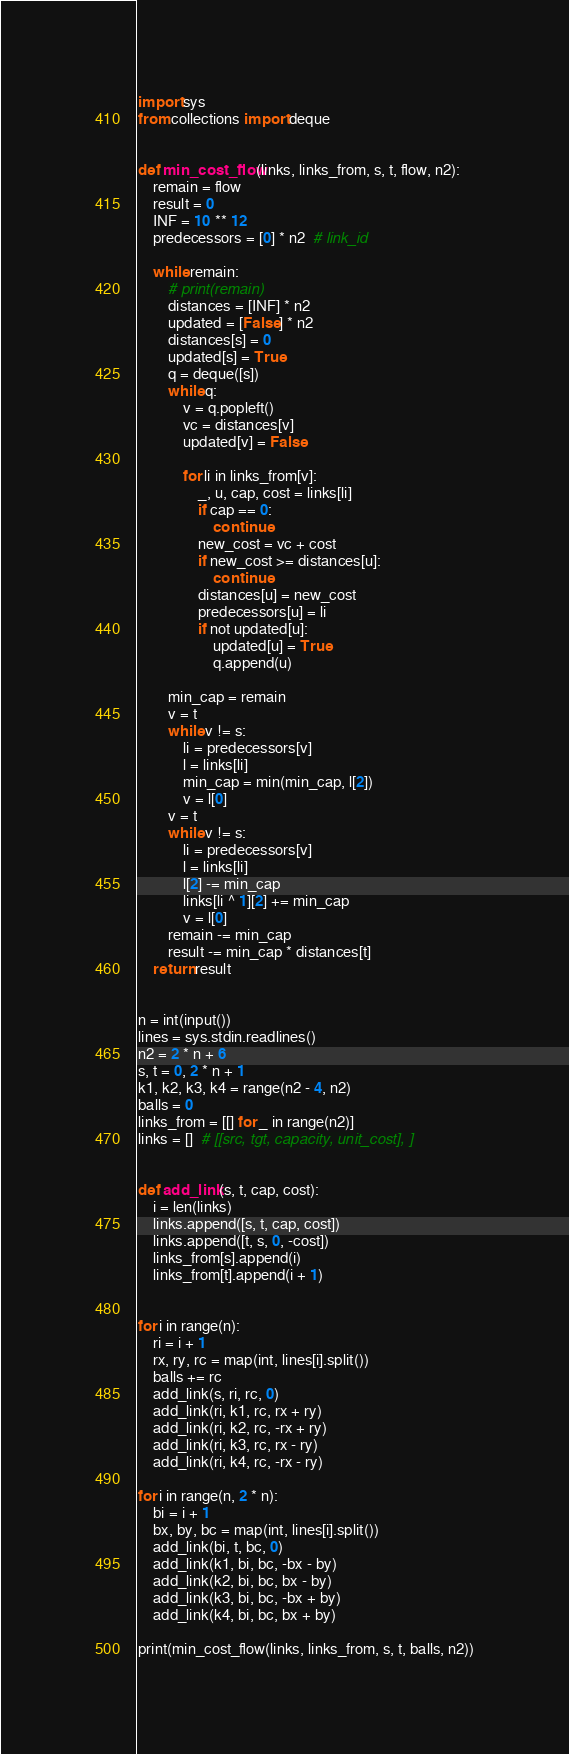<code> <loc_0><loc_0><loc_500><loc_500><_Python_>import sys
from collections import deque


def min_cost_flow(links, links_from, s, t, flow, n2):
    remain = flow
    result = 0
    INF = 10 ** 12
    predecessors = [0] * n2  # link_id

    while remain:
        # print(remain)
        distances = [INF] * n2
        updated = [False] * n2
        distances[s] = 0
        updated[s] = True
        q = deque([s])
        while q:
            v = q.popleft()
            vc = distances[v]
            updated[v] = False

            for li in links_from[v]:
                _, u, cap, cost = links[li]
                if cap == 0:
                    continue
                new_cost = vc + cost
                if new_cost >= distances[u]:
                    continue
                distances[u] = new_cost
                predecessors[u] = li
                if not updated[u]:
                    updated[u] = True
                    q.append(u)

        min_cap = remain
        v = t
        while v != s:
            li = predecessors[v]
            l = links[li]
            min_cap = min(min_cap, l[2])
            v = l[0]
        v = t
        while v != s:
            li = predecessors[v]
            l = links[li]
            l[2] -= min_cap
            links[li ^ 1][2] += min_cap
            v = l[0]
        remain -= min_cap
        result -= min_cap * distances[t]
    return result


n = int(input())
lines = sys.stdin.readlines()
n2 = 2 * n + 6
s, t = 0, 2 * n + 1
k1, k2, k3, k4 = range(n2 - 4, n2)
balls = 0
links_from = [[] for _ in range(n2)]
links = []  # [[src, tgt, capacity, unit_cost], ]


def add_link(s, t, cap, cost):
    i = len(links)
    links.append([s, t, cap, cost])
    links.append([t, s, 0, -cost])
    links_from[s].append(i)
    links_from[t].append(i + 1)


for i in range(n):
    ri = i + 1
    rx, ry, rc = map(int, lines[i].split())
    balls += rc
    add_link(s, ri, rc, 0)
    add_link(ri, k1, rc, rx + ry)
    add_link(ri, k2, rc, -rx + ry)
    add_link(ri, k3, rc, rx - ry)
    add_link(ri, k4, rc, -rx - ry)

for i in range(n, 2 * n):
    bi = i + 1
    bx, by, bc = map(int, lines[i].split())
    add_link(bi, t, bc, 0)
    add_link(k1, bi, bc, -bx - by)
    add_link(k2, bi, bc, bx - by)
    add_link(k3, bi, bc, -bx + by)
    add_link(k4, bi, bc, bx + by)

print(min_cost_flow(links, links_from, s, t, balls, n2))
</code> 